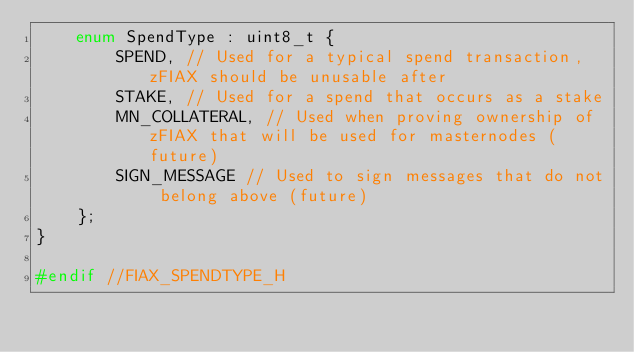Convert code to text. <code><loc_0><loc_0><loc_500><loc_500><_C_>    enum SpendType : uint8_t {
        SPEND, // Used for a typical spend transaction, zFIAX should be unusable after
        STAKE, // Used for a spend that occurs as a stake
        MN_COLLATERAL, // Used when proving ownership of zFIAX that will be used for masternodes (future)
        SIGN_MESSAGE // Used to sign messages that do not belong above (future)
    };
}

#endif //FIAX_SPENDTYPE_H
</code> 